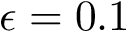Convert formula to latex. <formula><loc_0><loc_0><loc_500><loc_500>\epsilon = 0 . 1</formula> 